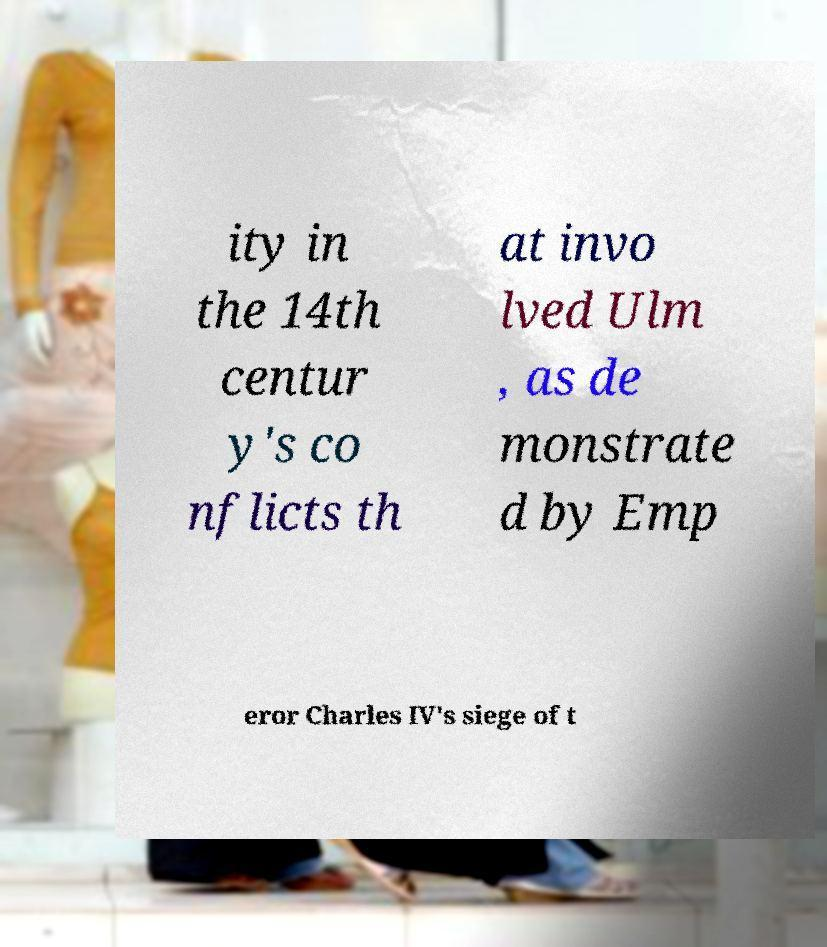Could you assist in decoding the text presented in this image and type it out clearly? ity in the 14th centur y's co nflicts th at invo lved Ulm , as de monstrate d by Emp eror Charles IV's siege of t 